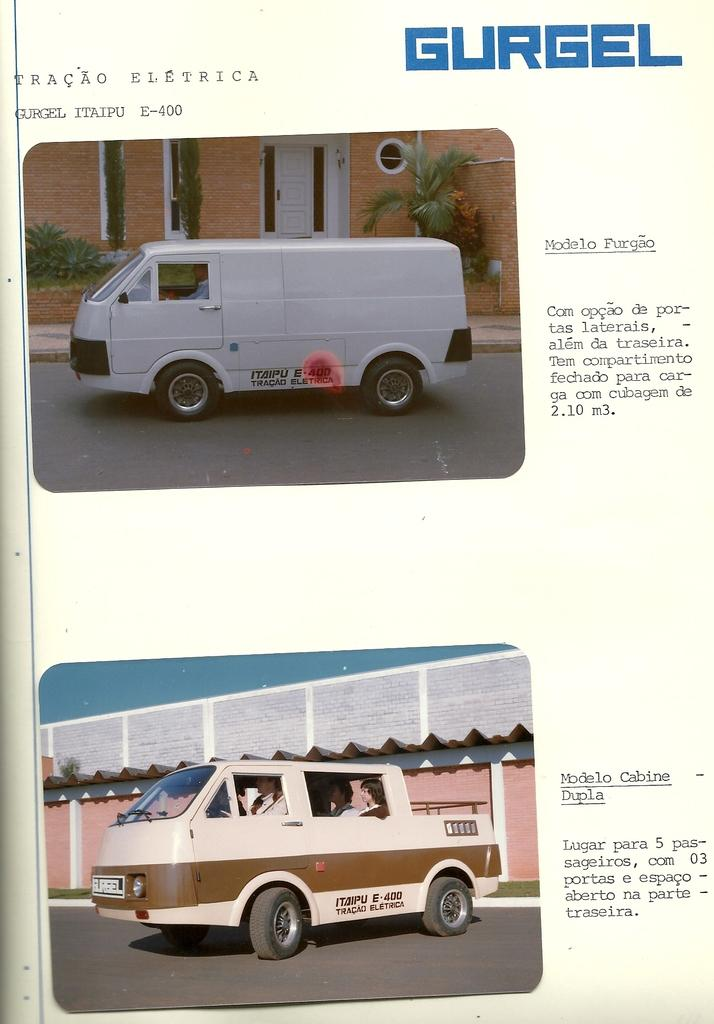How many vehicles are present in the image? There are two vans in the image. What advice does the corn give to the dog in the image? There is no corn or dog present in the image, so no such interaction or advice can be observed. 